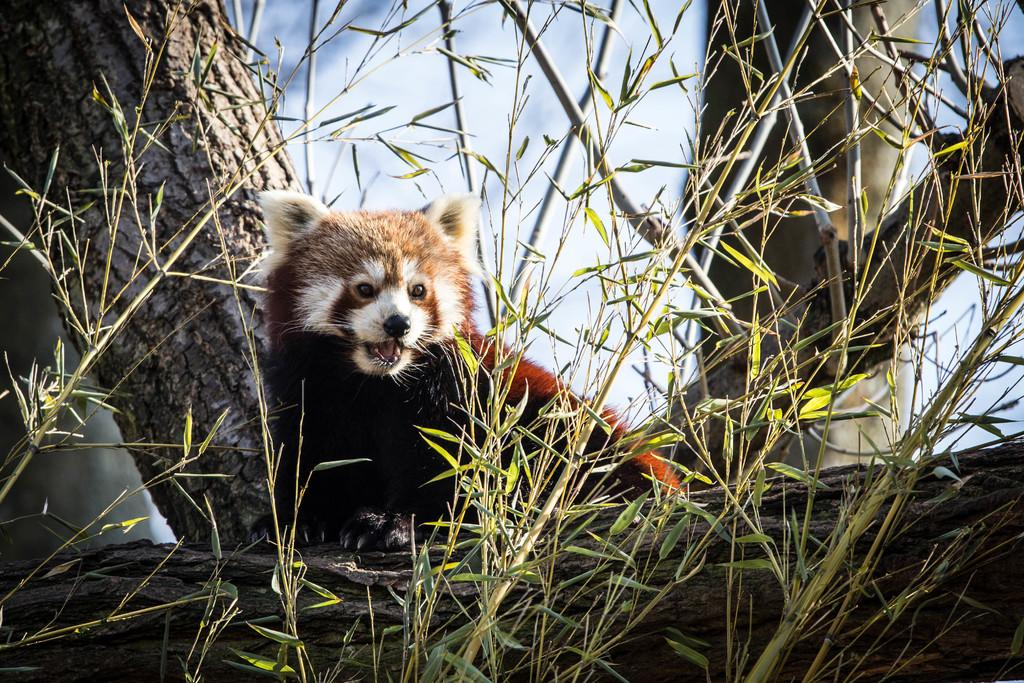What type of animal can be seen in the image? There is an animal in the image in the image, but its specific type cannot be determined from the provided facts. Where is the animal located in the image? The animal is on a wooden branch of a tree in the image. What is visible in the foreground of the image? There is grass in the foreground of the image. What type of chalk is being used to draw on the cloud in the image? There is no cloud or chalk present in the image; it features an animal on a wooden branch of a tree with grass in the foreground. 